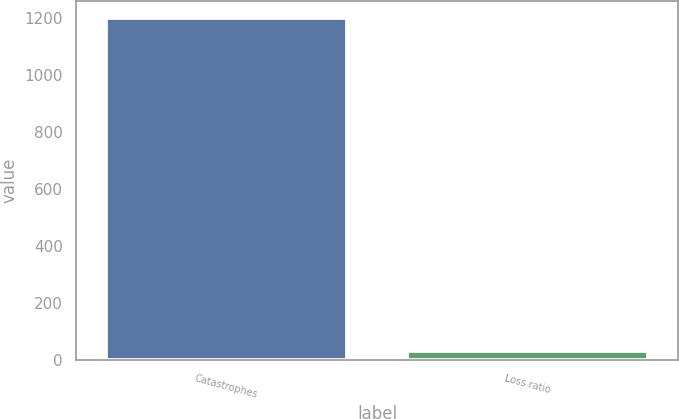Convert chart to OTSL. <chart><loc_0><loc_0><loc_500><loc_500><bar_chart><fcel>Catastrophes<fcel>Loss ratio<nl><fcel>1197.8<fcel>30.8<nl></chart> 